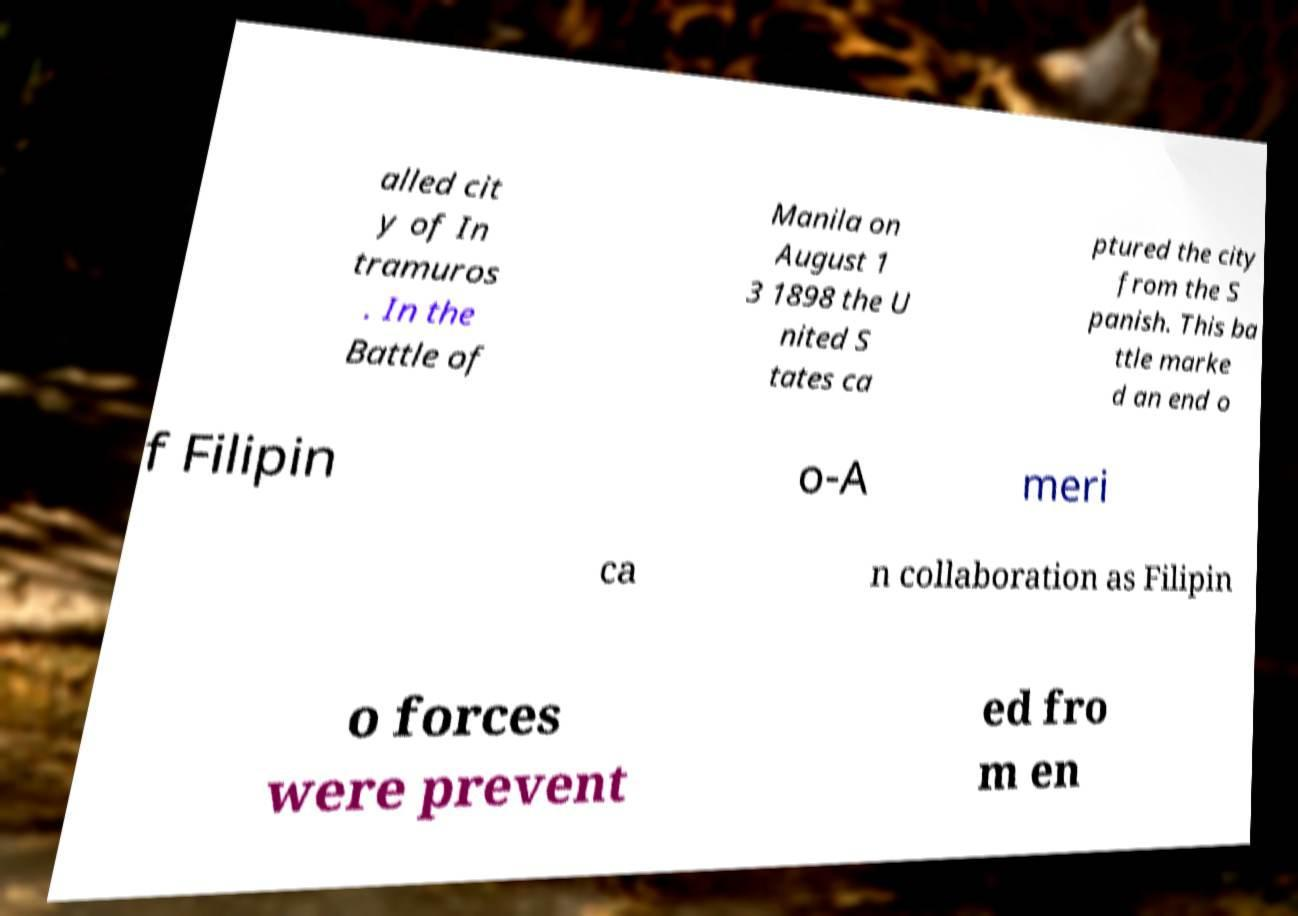Please identify and transcribe the text found in this image. alled cit y of In tramuros . In the Battle of Manila on August 1 3 1898 the U nited S tates ca ptured the city from the S panish. This ba ttle marke d an end o f Filipin o-A meri ca n collaboration as Filipin o forces were prevent ed fro m en 